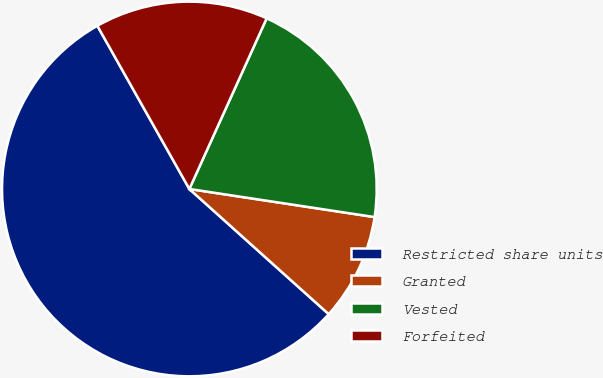Convert chart to OTSL. <chart><loc_0><loc_0><loc_500><loc_500><pie_chart><fcel>Restricted share units<fcel>Granted<fcel>Vested<fcel>Forfeited<nl><fcel>55.18%<fcel>9.25%<fcel>20.63%<fcel>14.94%<nl></chart> 